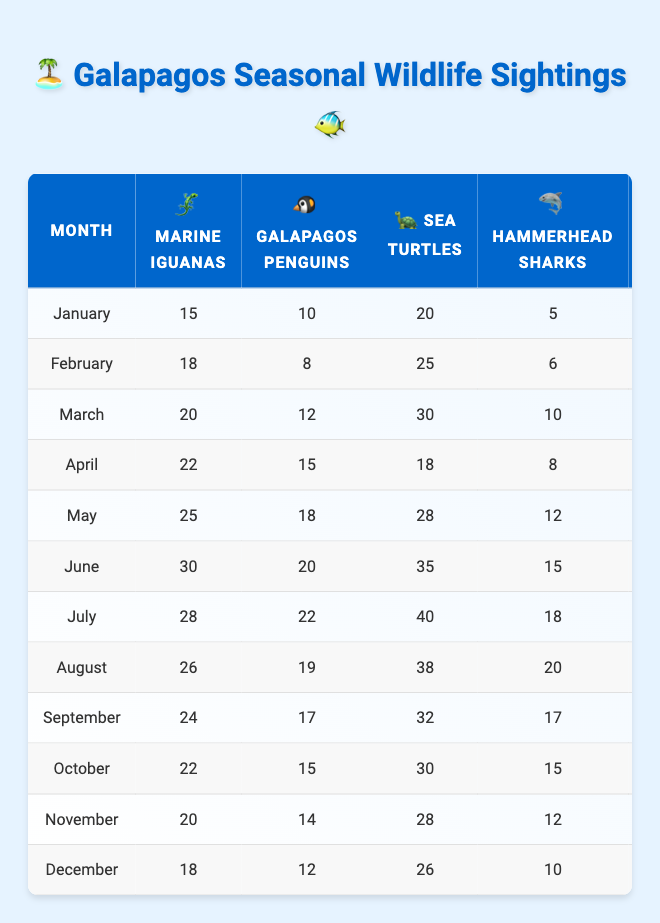What is the highest number of Sea Turtles sighted in a month? The highest number of Sea Turtles sighted is in July with 40 sightings. I identified this by scanning through the Sea Turtle column across all months to find the maximum value.
Answer: 40 Which month had the most Hammerhead Sharks sightings? The month with the most Hammerhead Sharks sightings is July with 18 sightings. I compared the values in the Hammerhead Sharks column for each month.
Answer: July Calculate the average number of Galapagos Penguins sighted from January to December. To find the average, I first total the number of Galapagos Penguins: (10 + 8 + 12 + 15 + 18 + 20 + 22 + 19 + 17 + 15 + 14 + 12) =  12.75. Then, I divide by the number of months, which is 12. Therefore, the average is 12.75.
Answer: 16 In which month do we see an increase in Marine Iguanas compared to the previous month for the first time? The first month to show an increase in Marine Iguanas compared to the previous month is February, where the amount increased from 15 in January to 18 in February. I tracked the Marine Iguanas data from month to month to pinpoint the first increase.
Answer: February True or False: The sightings of Manta Rays were consistently above 20 from March through November. False. I checked the Manta Rays column; while there are sightings above 20 in March through July, sightings fall below 20 in November at only 19. Therefore, the statement is false.
Answer: False What is the total number of sightings for all species in the month of June? The total sightings in June is calculated by adding together all species: (30 + 20 + 35 + 15 + 28) = 128. I summed the values from June for each species to reach this total.
Answer: 128 What is the difference in the number of Sea Turtles sighted in March and the following month, April? The difference between sightings in March (30) and April (18) is calculated as 30 - 18 = 12. I looked at the values for both months and performed the subtraction.
Answer: 12 Which month had the lowest sightings of Galapagos Penguins? The month with the lowest sightings of Galapagos Penguins is February with 8 sightings. I scanned through the Galapagos Penguins column to find the minimum value.
Answer: February Is the total number of Marine Iguanas sighted in the first half of the year greater than the total in the second half? Yes, the total in the first half (January to June) is 15 + 18 + 20 + 22 + 25 + 30 = 130, while the second half (July to December) totals 28 + 26 + 24 + 22 + 20 + 18 = 144. The total in the second half is greater, hence the answer is yes.
Answer: Yes What is the most significant decline in sightings for any species from one month to the next? The most significant decline is seen in Galapagos Penguins from April (15) to May (18), where there is a drop of 7. I compared the differences for all species across the months to find the maximum drop.
Answer: 7 